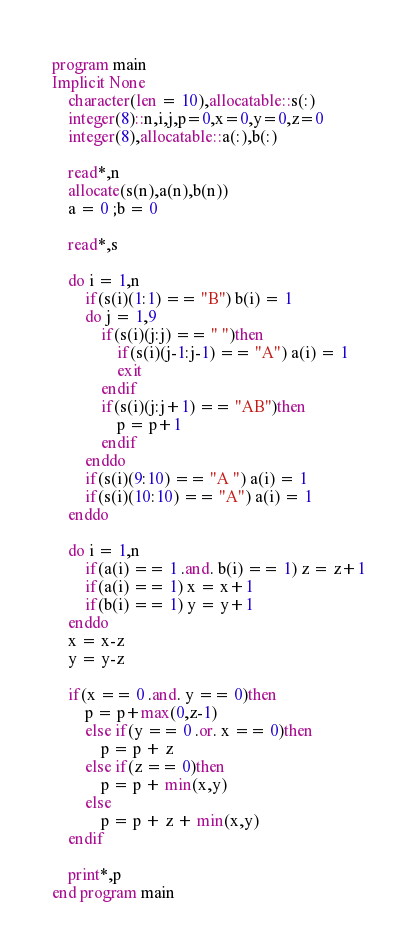<code> <loc_0><loc_0><loc_500><loc_500><_FORTRAN_>program main
Implicit None
	character(len = 10),allocatable::s(:)
	integer(8)::n,i,j,p=0,x=0,y=0,z=0
	integer(8),allocatable::a(:),b(:)
	
	read*,n
	allocate(s(n),a(n),b(n))
	a = 0 ;b = 0
	
	read*,s
	
	do i = 1,n
		if(s(i)(1:1) == "B") b(i) = 1
		do j = 1,9
			if(s(i)(j:j) == " ")then
				if(s(i)(j-1:j-1) == "A") a(i) = 1
				exit
			endif
			if(s(i)(j:j+1) == "AB")then
				p = p+1
			endif
		enddo
		if(s(i)(9:10) == "A ") a(i) = 1
		if(s(i)(10:10) == "A") a(i) = 1
	enddo
	
	do i = 1,n
		if(a(i) == 1 .and. b(i) == 1) z = z+1
		if(a(i) == 1) x = x+1
		if(b(i) == 1) y = y+1
	enddo
	x = x-z
	y = y-z
	
	if(x == 0 .and. y == 0)then
		p = p+max(0,z-1)
		else if(y == 0 .or. x == 0)then
			p = p + z
		else if(z == 0)then
			p = p + min(x,y)
		else
			p = p + z + min(x,y)
	endif
	
	print*,p
end program main</code> 